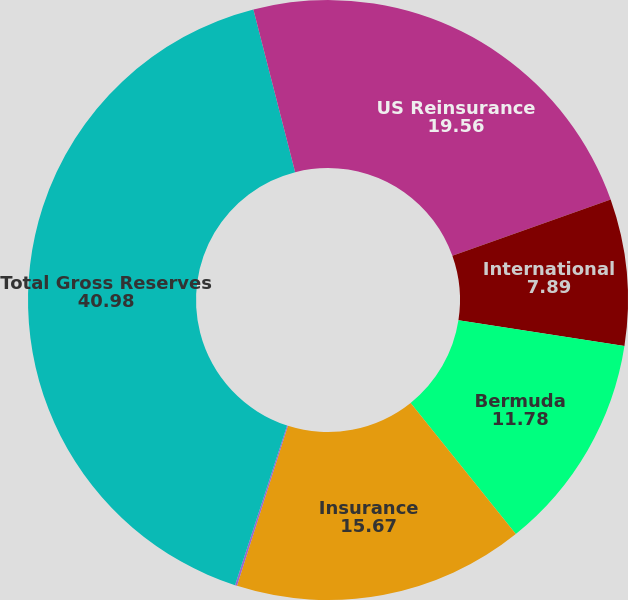Convert chart. <chart><loc_0><loc_0><loc_500><loc_500><pie_chart><fcel>US Reinsurance<fcel>International<fcel>Bermuda<fcel>Insurance<fcel>Mt Logan Re<fcel>Total Gross Reserves<fcel>A&E (All Segments)<nl><fcel>19.56%<fcel>7.89%<fcel>11.78%<fcel>15.67%<fcel>0.11%<fcel>40.98%<fcel>4.0%<nl></chart> 